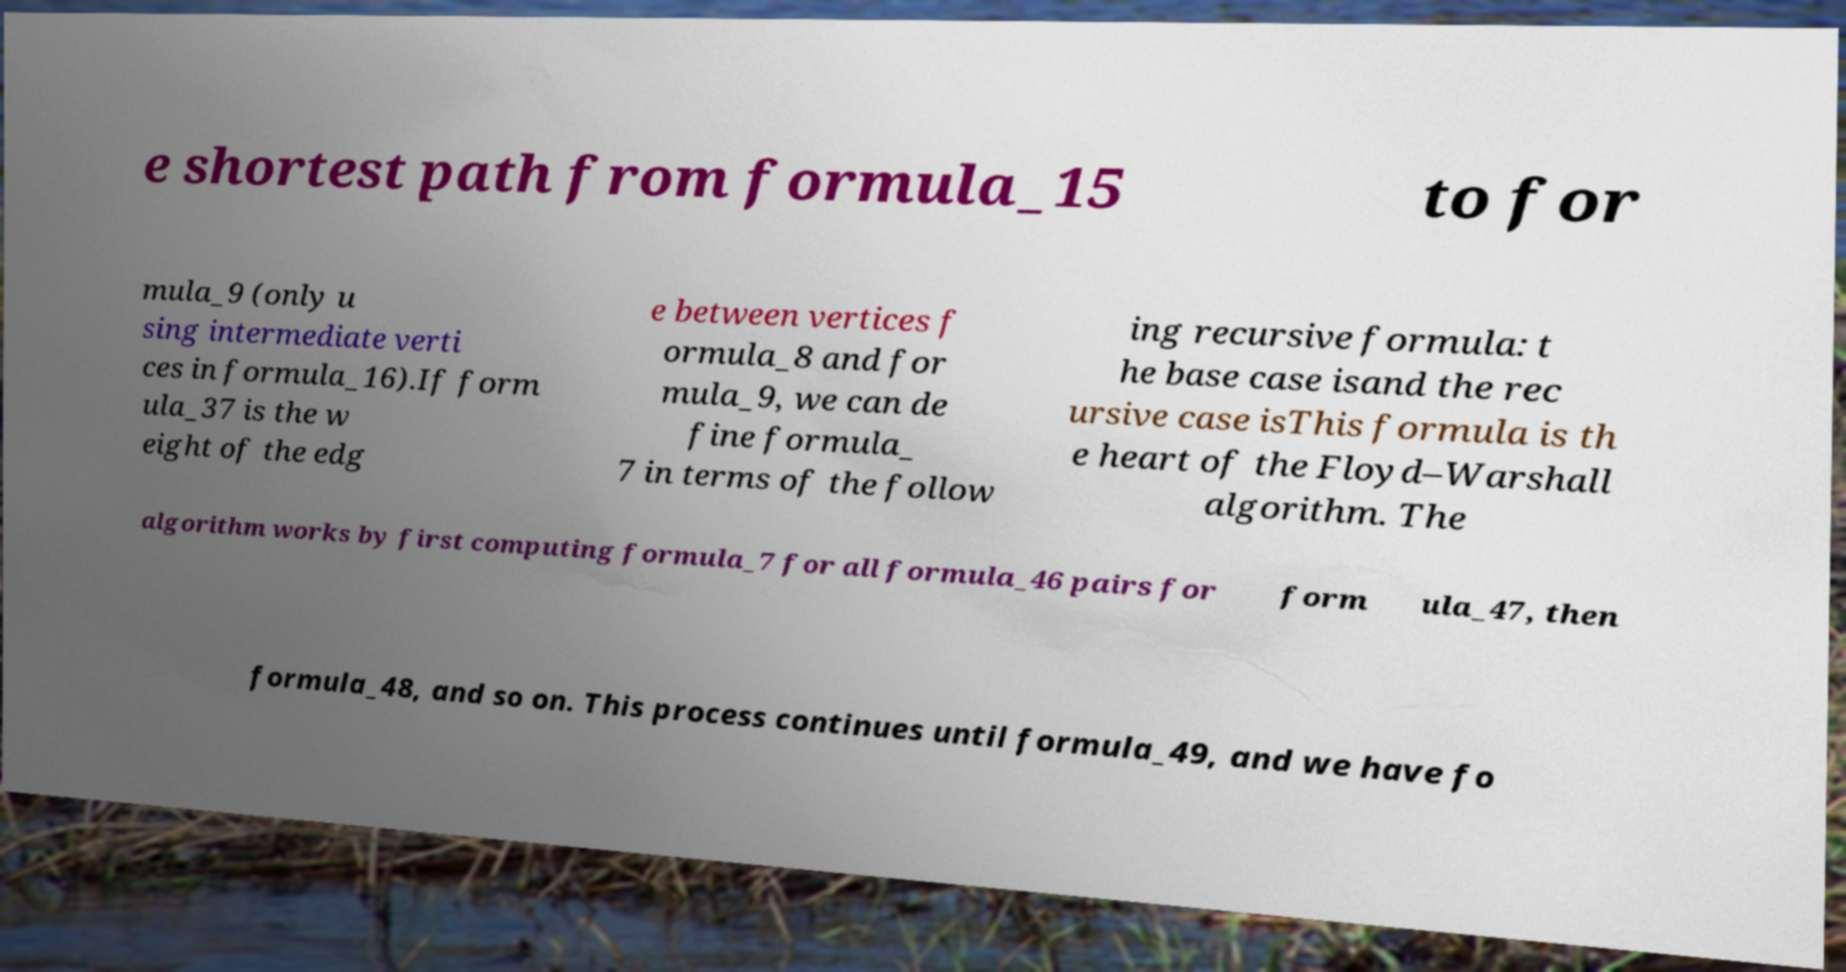Could you extract and type out the text from this image? e shortest path from formula_15 to for mula_9 (only u sing intermediate verti ces in formula_16).If form ula_37 is the w eight of the edg e between vertices f ormula_8 and for mula_9, we can de fine formula_ 7 in terms of the follow ing recursive formula: t he base case isand the rec ursive case isThis formula is th e heart of the Floyd–Warshall algorithm. The algorithm works by first computing formula_7 for all formula_46 pairs for form ula_47, then formula_48, and so on. This process continues until formula_49, and we have fo 